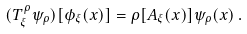<formula> <loc_0><loc_0><loc_500><loc_500>( T _ { \xi } ^ { \rho } \psi _ { \rho } ) [ \phi _ { \xi } ( x ) ] = \rho [ A _ { \xi } ( x ) ] \psi _ { \rho } ( x ) \, .</formula> 